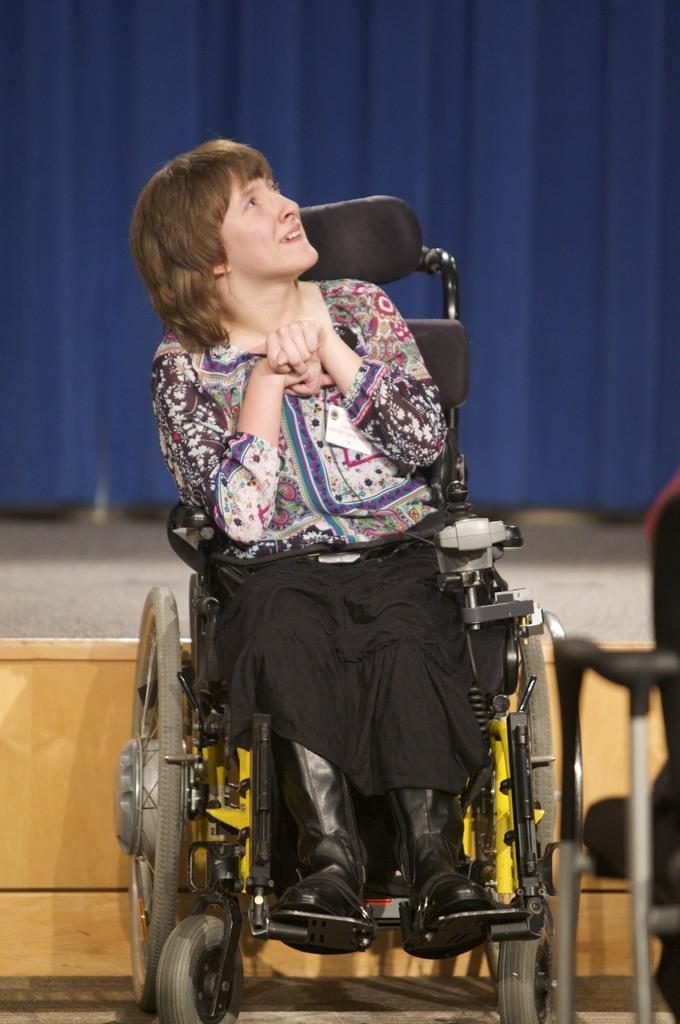How would you summarize this image in a sentence or two? In this image we can see a woman sitting on the wheelchair. In the background we can see the stage, blue color curtain and we can also see a chair on the right. 